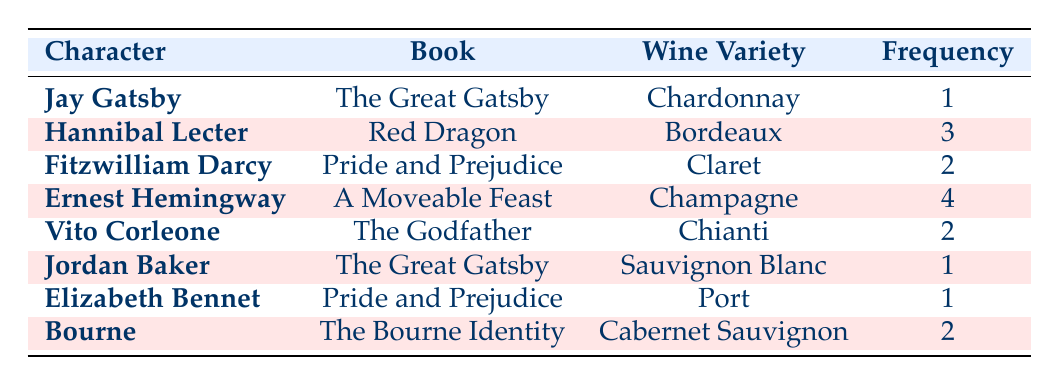What wine variety is most frequently mentioned? From the table, we can check the frequency column for each wine variety. The maximum frequency is 4 for Champagne, associated with Ernest Hemingway.
Answer: Champagne How many different wine varieties are mentioned? The table lists 8 distinct wine varieties (Chardonnay, Bordeaux, Claret, Champagne, Chianti, Sauvignon Blanc, Port, Cabernet Sauvignon) based on the characters.
Answer: 8 Is there a character who drinks Chardonnay? By looking at the wine variety column, we see that Jay Gatsby is associated with Chardonnay. Therefore, the statement is true.
Answer: Yes Which character is associated with the highest frequency of wine mentions? Scanning through the frequency column, we see that Ernest Hemingway has the highest frequency with a value of 4.
Answer: Ernest Hemingway What is the total frequency of wine mentions for the character Fitzwilliam Darcy? Fitzwilliam Darcy appears once in the table with a frequency of 2 for Claret. Therefore, the total frequency for this character is 2.
Answer: 2 Are there any characters who drink Port? The table shows that Elizabeth Bennet is associated with Port, indicating that the answer is yes.
Answer: Yes Which wine variety is associated with Vito Corleone? By referring to the table, we can see that Vito Corleone is associated with Chianti.
Answer: Chianti What is the average frequency of wine mentions among all characters? To calculate the average frequency, we sum all the frequencies: 1 + 3 + 2 + 4 + 2 + 1 + 1 + 2 = 16. There are 8 characters, so the average is 16/8 = 2.
Answer: 2 Which wine variety has the lowest frequency in the table? Looking at the frequency column, we find that Chardonnay, Sauvignon Blanc, and Port are all mentioned once (frequency = 1). Therefore, these varieties are tied for the lowest frequency.
Answer: Chardonnay, Sauvignon Blanc, Port 